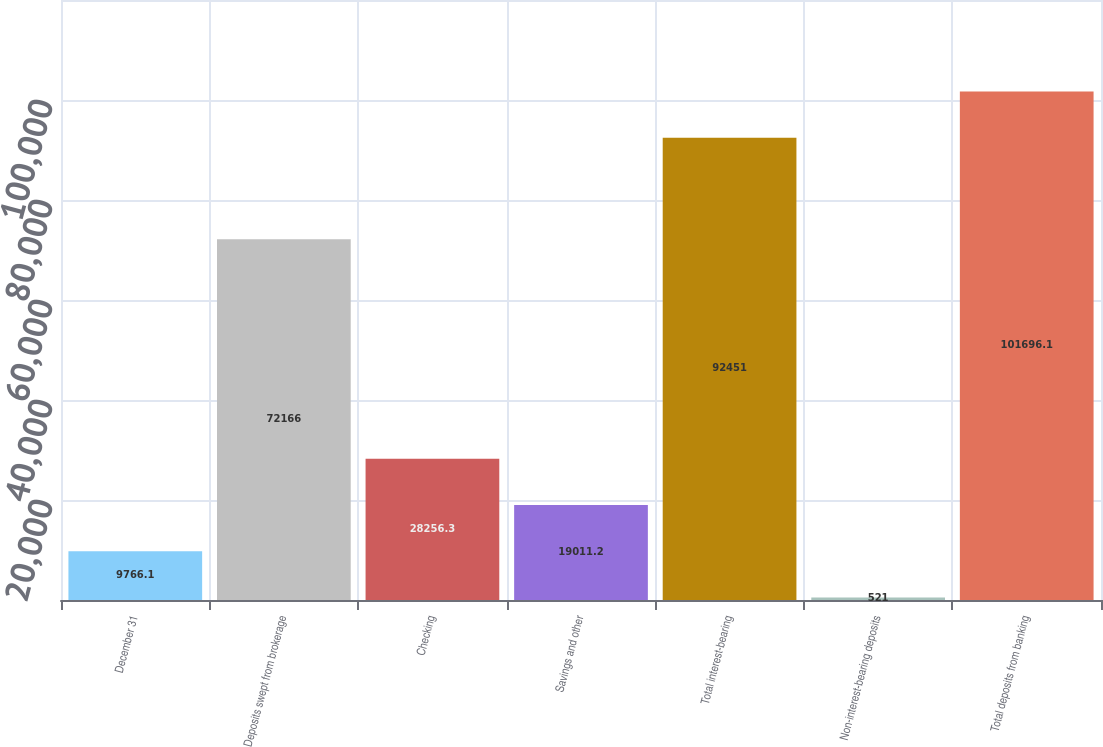Convert chart. <chart><loc_0><loc_0><loc_500><loc_500><bar_chart><fcel>December 31<fcel>Deposits swept from brokerage<fcel>Checking<fcel>Savings and other<fcel>Total interest-bearing<fcel>Non-interest-bearing deposits<fcel>Total deposits from banking<nl><fcel>9766.1<fcel>72166<fcel>28256.3<fcel>19011.2<fcel>92451<fcel>521<fcel>101696<nl></chart> 